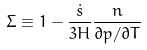Convert formula to latex. <formula><loc_0><loc_0><loc_500><loc_500>\Sigma \equiv 1 - \frac { \dot { s } } { 3 H } \frac { n } { \partial p / \partial T } \</formula> 